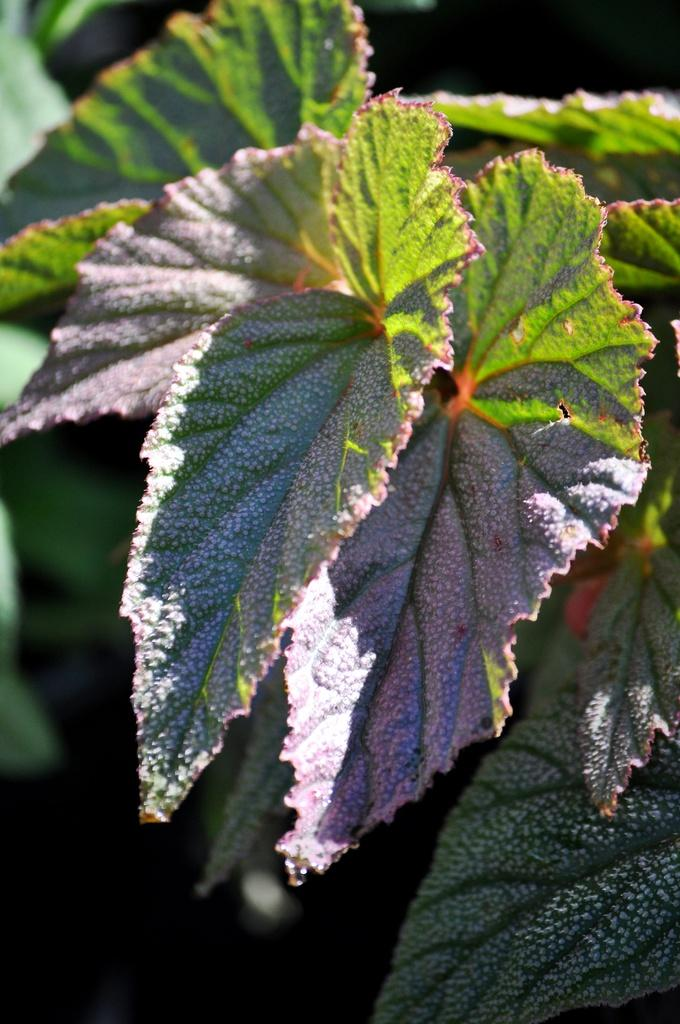What type of vegetation can be seen in the image? There are leaves in the image. What type of stew is being prepared in the image? There is no stew present in the image; it only features leaves. What type of engine can be seen in the image? There is no engine present in the image; it only features leaves. 